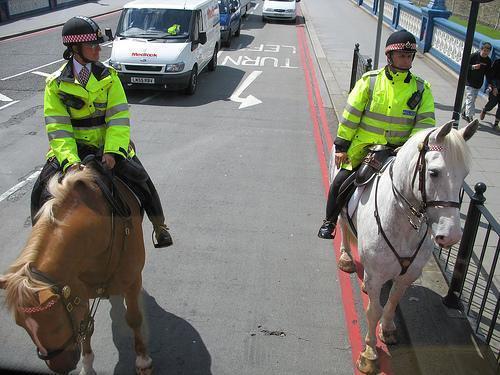How many horses are there?
Give a very brief answer. 2. 